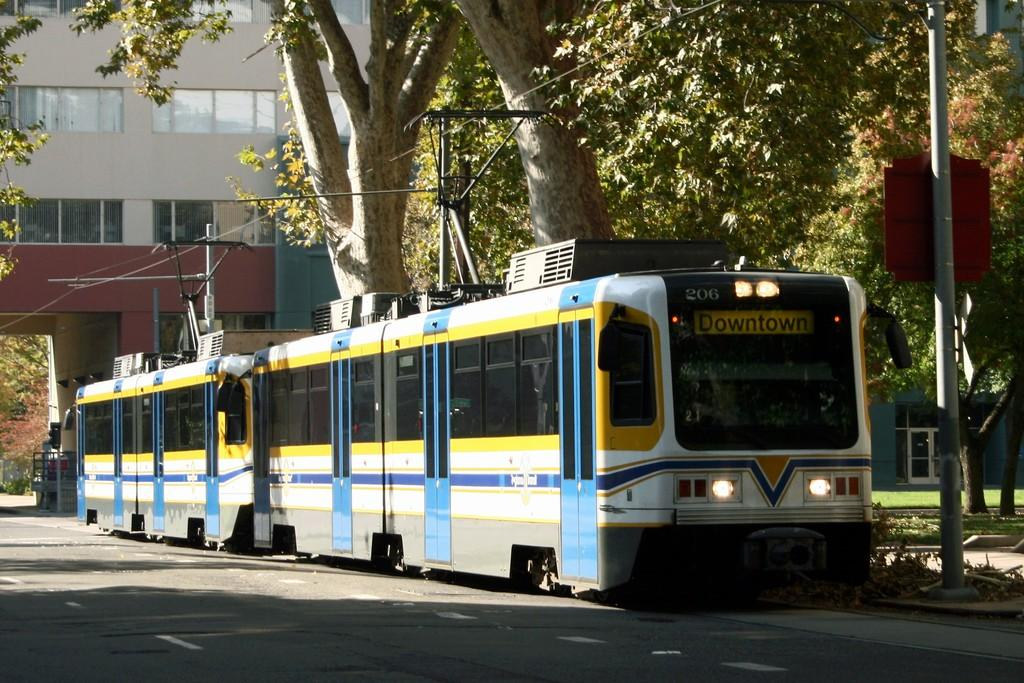What is on the road in the image? There is a vehicle on the road in the image. What type of vegetation can be seen in the image? There are trees in the image. What object is present in the image that might be used for displaying information or advertisements? There is a board in the image. What type of structures are present in the image? There are poles and a building in the image. What might be used for transmitting electricity or communication signals in the image? There are wires in the image. What can be seen in the background of the image? There is a building, grass, and a traffic signal on a pole in the background of the image. What feature of the building is visible in the image? There are windows visible in the background of the image. What type of minister is offering a foot massage in the image? There is no minister or foot massage present in the image. What type of footwear is visible on the vehicle in the image? There is no footwear visible on the vehicle in the image. 